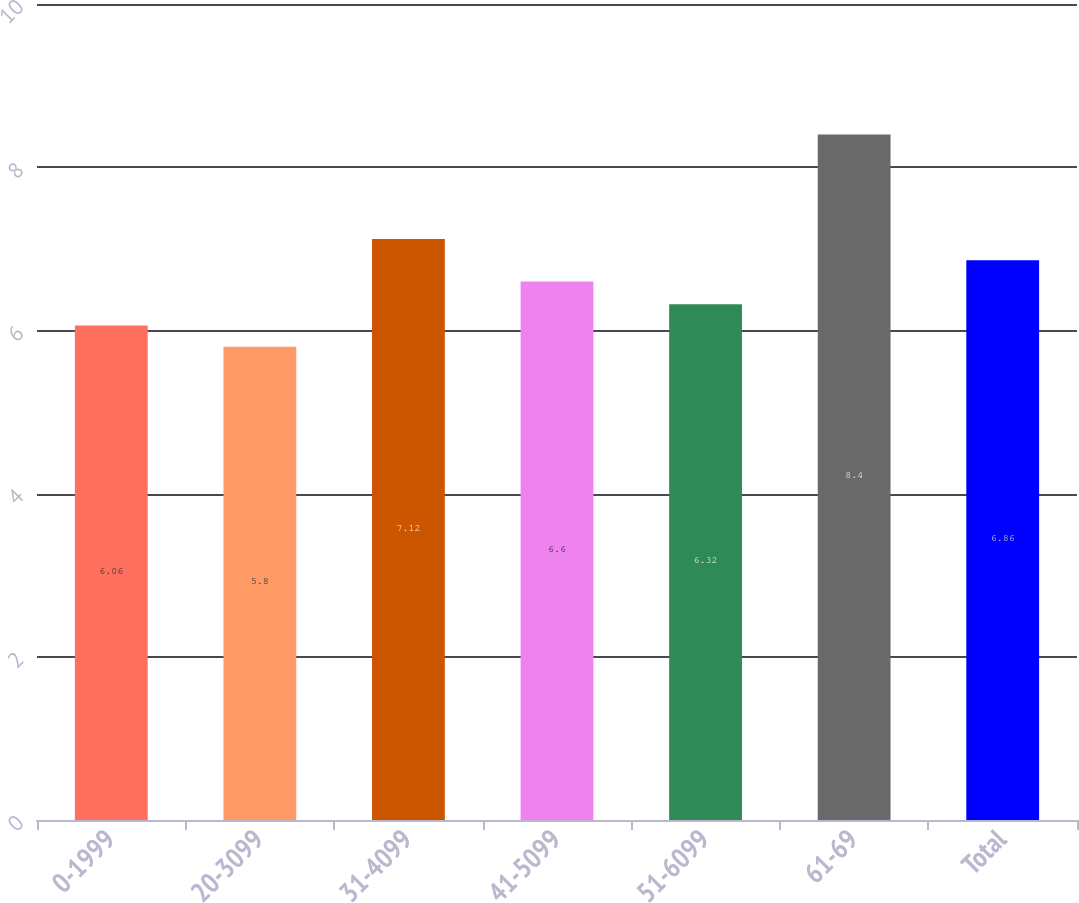<chart> <loc_0><loc_0><loc_500><loc_500><bar_chart><fcel>0-1999<fcel>20-3099<fcel>31-4099<fcel>41-5099<fcel>51-6099<fcel>61-69<fcel>Total<nl><fcel>6.06<fcel>5.8<fcel>7.12<fcel>6.6<fcel>6.32<fcel>8.4<fcel>6.86<nl></chart> 